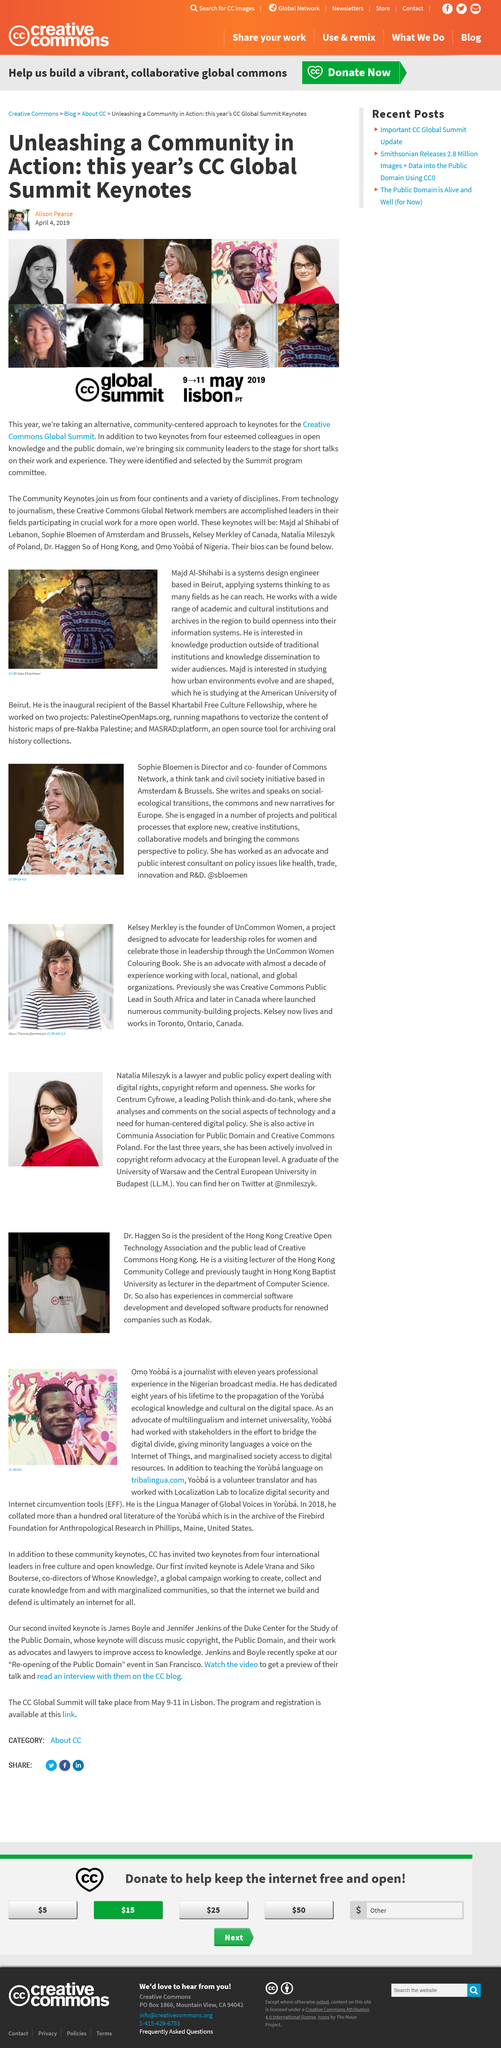Outline some significant characteristics in this image. Alison Pearce wrote and published the article on April 4, 2019. In 2018, he collated the oral literature of the Yoruba tribe. The speaker studied at the American University of Beirut. Majd Al-Shihabi is based in Beirut, the city where she resides. Yooba, as an advocate for minority languages, worked to ensure that these languages had a voice in the discussion surrounding the Internet of Things and to provide marginalized communities with access to digital resources. 